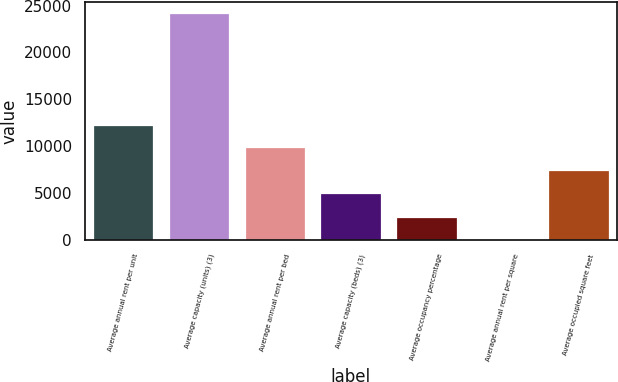Convert chart. <chart><loc_0><loc_0><loc_500><loc_500><bar_chart><fcel>Average annual rent per unit<fcel>Average capacity (units) (3)<fcel>Average annual rent per bed<fcel>Average capacity (beds) (3)<fcel>Average occupancy percentage<fcel>Average annual rent per square<fcel>Average occupied square feet<nl><fcel>12290.8<fcel>24209<fcel>9874.2<fcel>5041<fcel>2459.6<fcel>43<fcel>7457.6<nl></chart> 